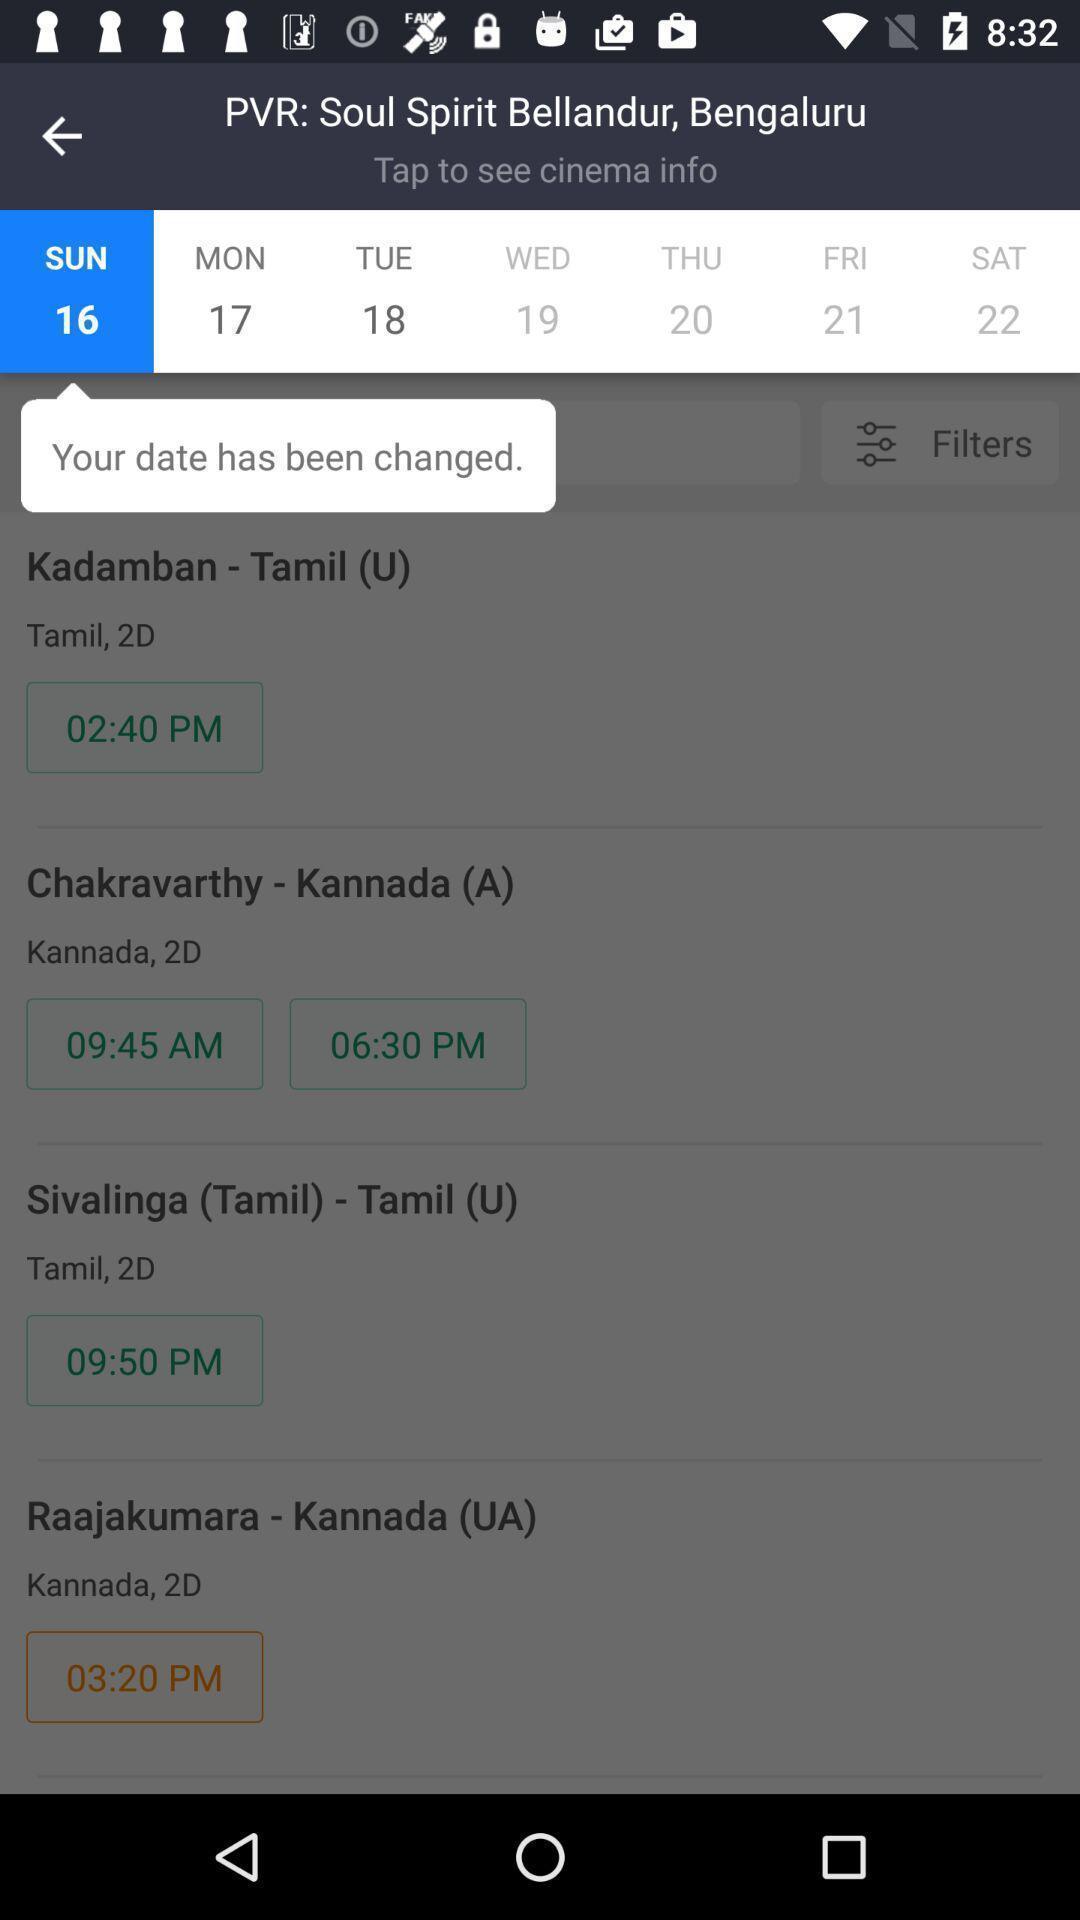Describe the key features of this screenshot. Screen displaying multiple options to book movie tickets. 